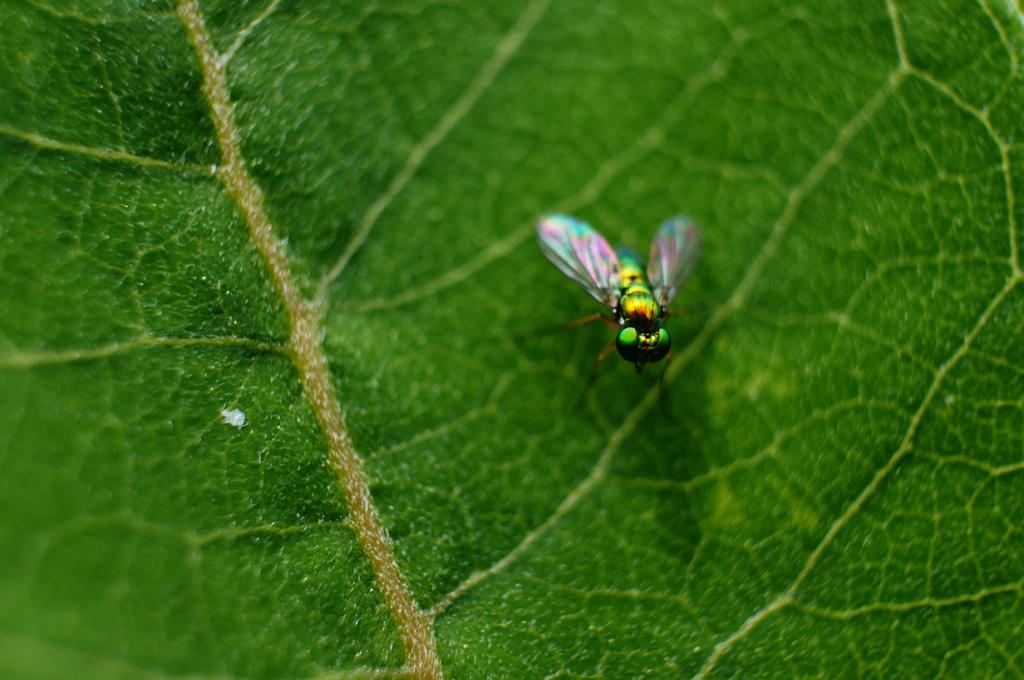What type of plant material is present in the image? There is a green leaf in the image. What is on the leaf in the image? There is a flying insect on the leaf. What type of structure can be seen in the background of the image? There is no structure visible in the image; it only features a green leaf with a flying insect on it. Can you see any waves in the image? There are no waves present in the image. 